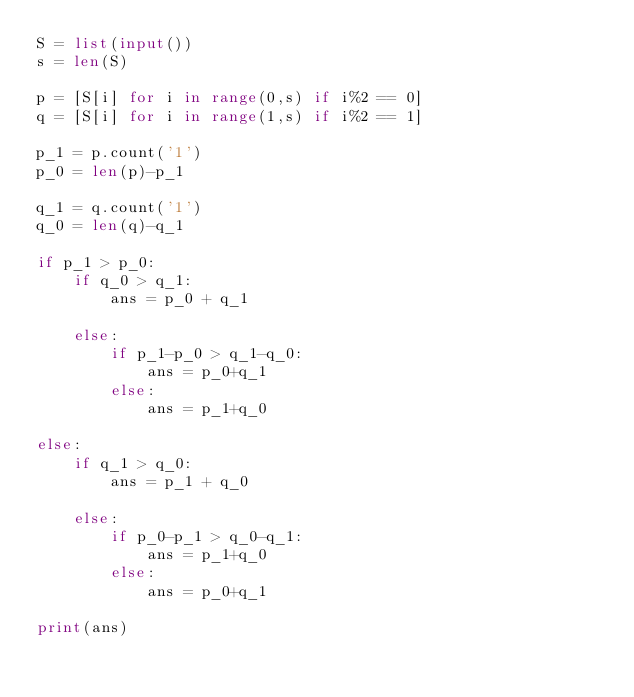<code> <loc_0><loc_0><loc_500><loc_500><_Python_>S = list(input())
s = len(S)

p = [S[i] for i in range(0,s) if i%2 == 0]
q = [S[i] for i in range(1,s) if i%2 == 1]

p_1 = p.count('1')
p_0 = len(p)-p_1

q_1 = q.count('1')
q_0 = len(q)-q_1

if p_1 > p_0:
    if q_0 > q_1:
        ans = p_0 + q_1

    else:
        if p_1-p_0 > q_1-q_0:
            ans = p_0+q_1
        else:
            ans = p_1+q_0

else:
    if q_1 > q_0:
        ans = p_1 + q_0

    else:
        if p_0-p_1 > q_0-q_1:
            ans = p_1+q_0
        else:
            ans = p_0+q_1

print(ans)
</code> 